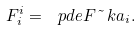Convert formula to latex. <formula><loc_0><loc_0><loc_500><loc_500>F ^ { i } _ { i } = \ p d e F { \tilde { \ } k a _ { i } } .</formula> 